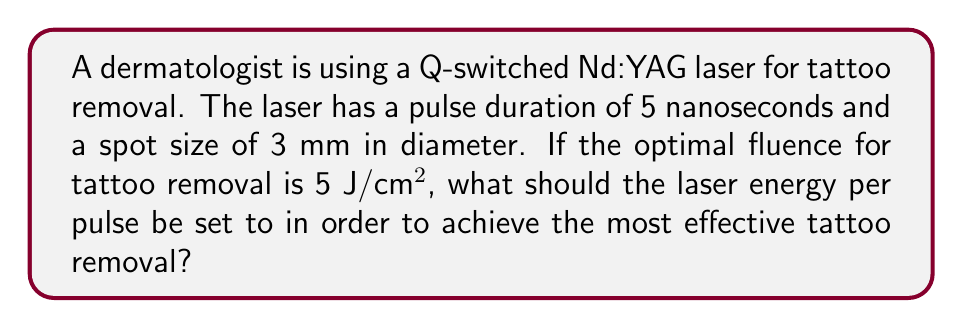Provide a solution to this math problem. To solve this problem, we need to follow these steps:

1. Calculate the area of the laser spot:
   The spot size is given as a circle with a diameter of 3 mm.
   Area = $\pi r^2 = \pi (\frac{d}{2})^2$
   $$ A = \pi (\frac{0.3 \text{ cm}}{2})^2 = 0.0707 \text{ cm}^2 $$

2. Calculate the required energy using the optimal fluence:
   Fluence is energy per unit area.
   Energy = Fluence × Area
   $$ E = 5 \text{ J/cm}^2 \times 0.0707 \text{ cm}^2 = 0.3535 \text{ J} $$

3. Convert the energy to millijoules for a more practical unit in laser settings:
   $$ E = 0.3535 \text{ J} \times 1000 \text{ mJ/J} = 353.5 \text{ mJ} $$

Therefore, the laser energy per pulse should be set to 353.5 mJ to achieve the optimal fluence for effective tattoo removal.
Answer: 353.5 mJ 